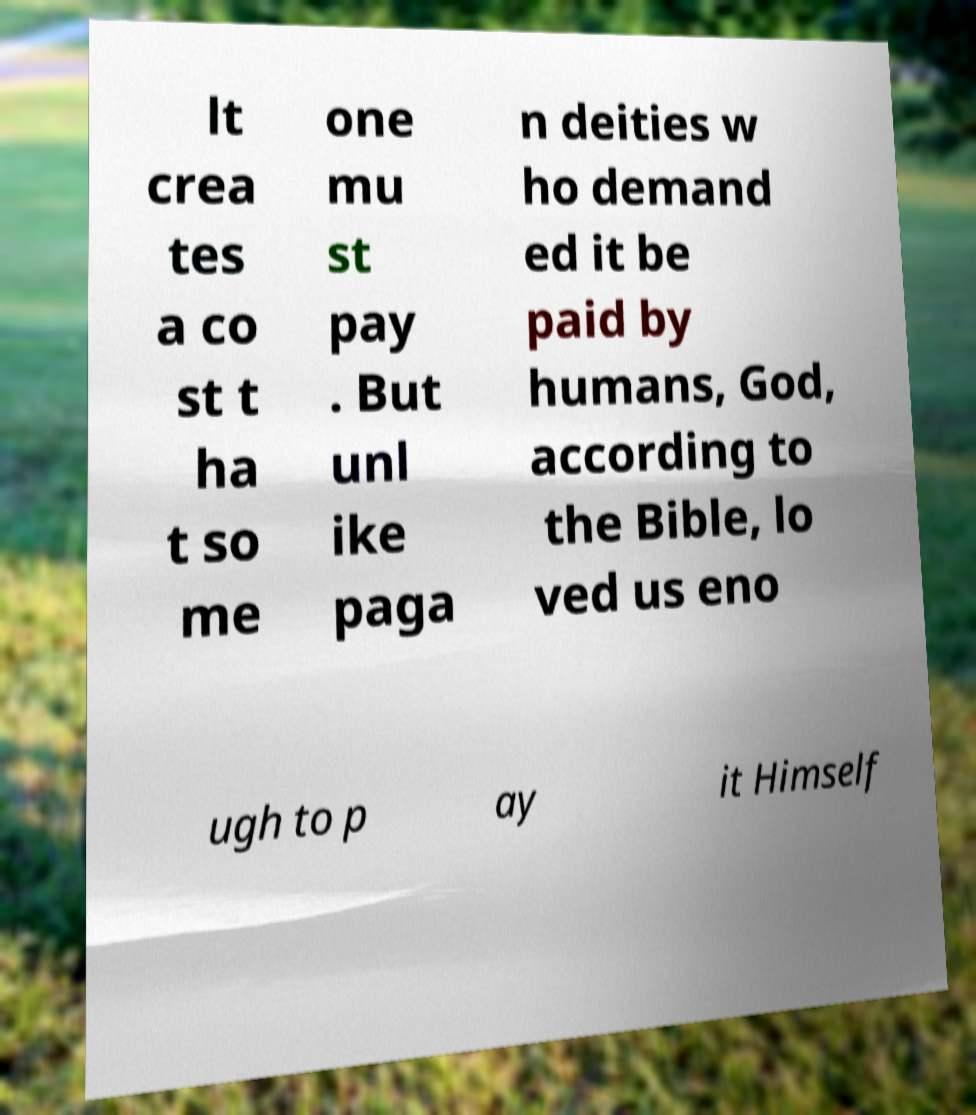For documentation purposes, I need the text within this image transcribed. Could you provide that? lt crea tes a co st t ha t so me one mu st pay . But unl ike paga n deities w ho demand ed it be paid by humans, God, according to the Bible, lo ved us eno ugh to p ay it Himself 